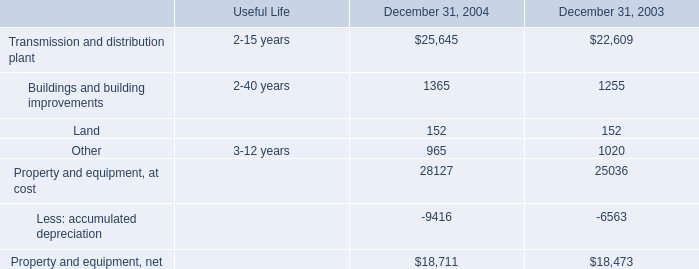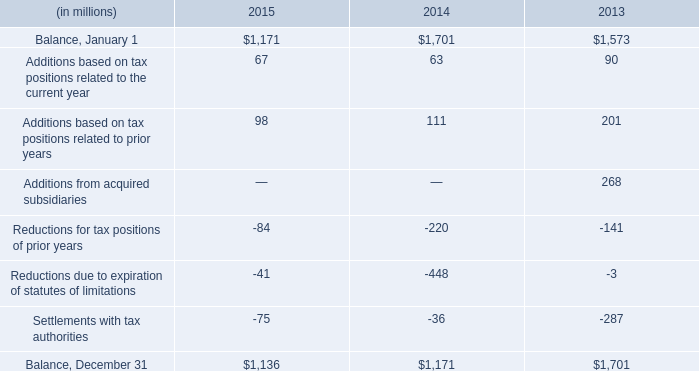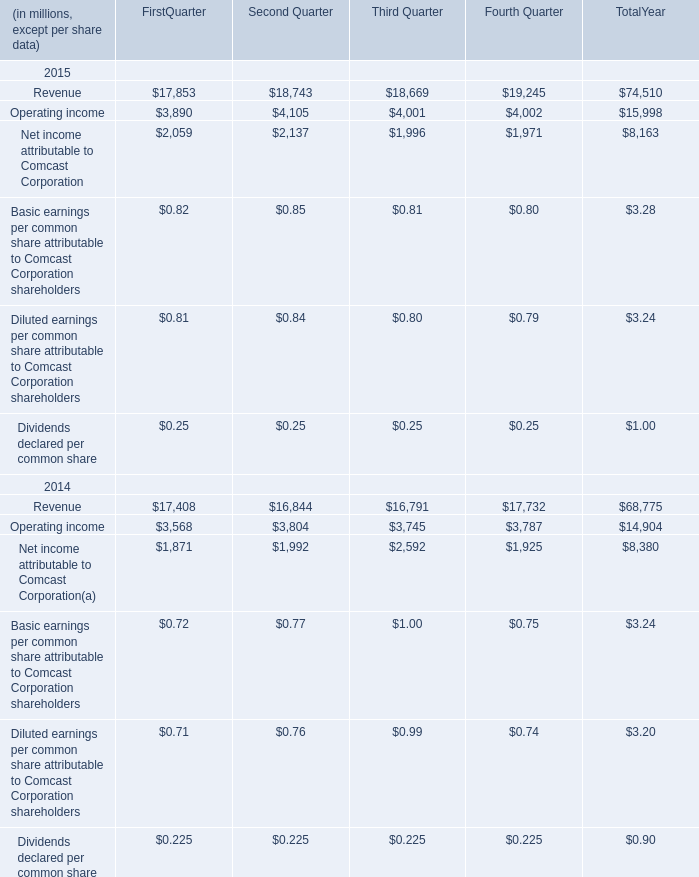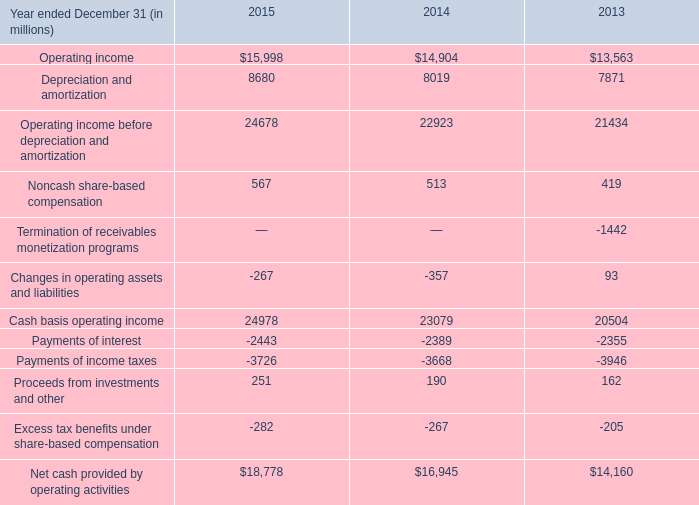What is the total amount of Balance, December 31 of 2014, and Payments of interest of 2015 ? 
Computations: (1171.0 + 2443.0)
Answer: 3614.0. 